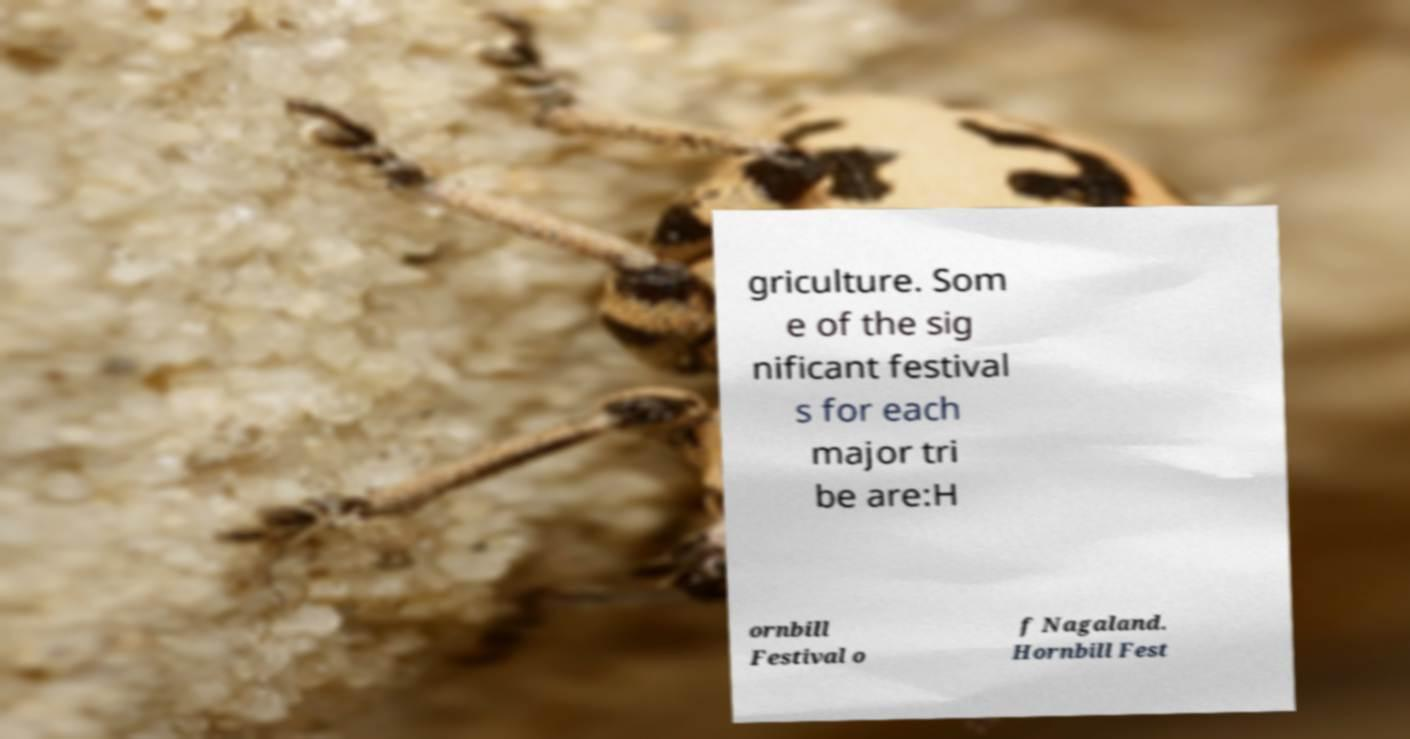For documentation purposes, I need the text within this image transcribed. Could you provide that? griculture. Som e of the sig nificant festival s for each major tri be are:H ornbill Festival o f Nagaland. Hornbill Fest 